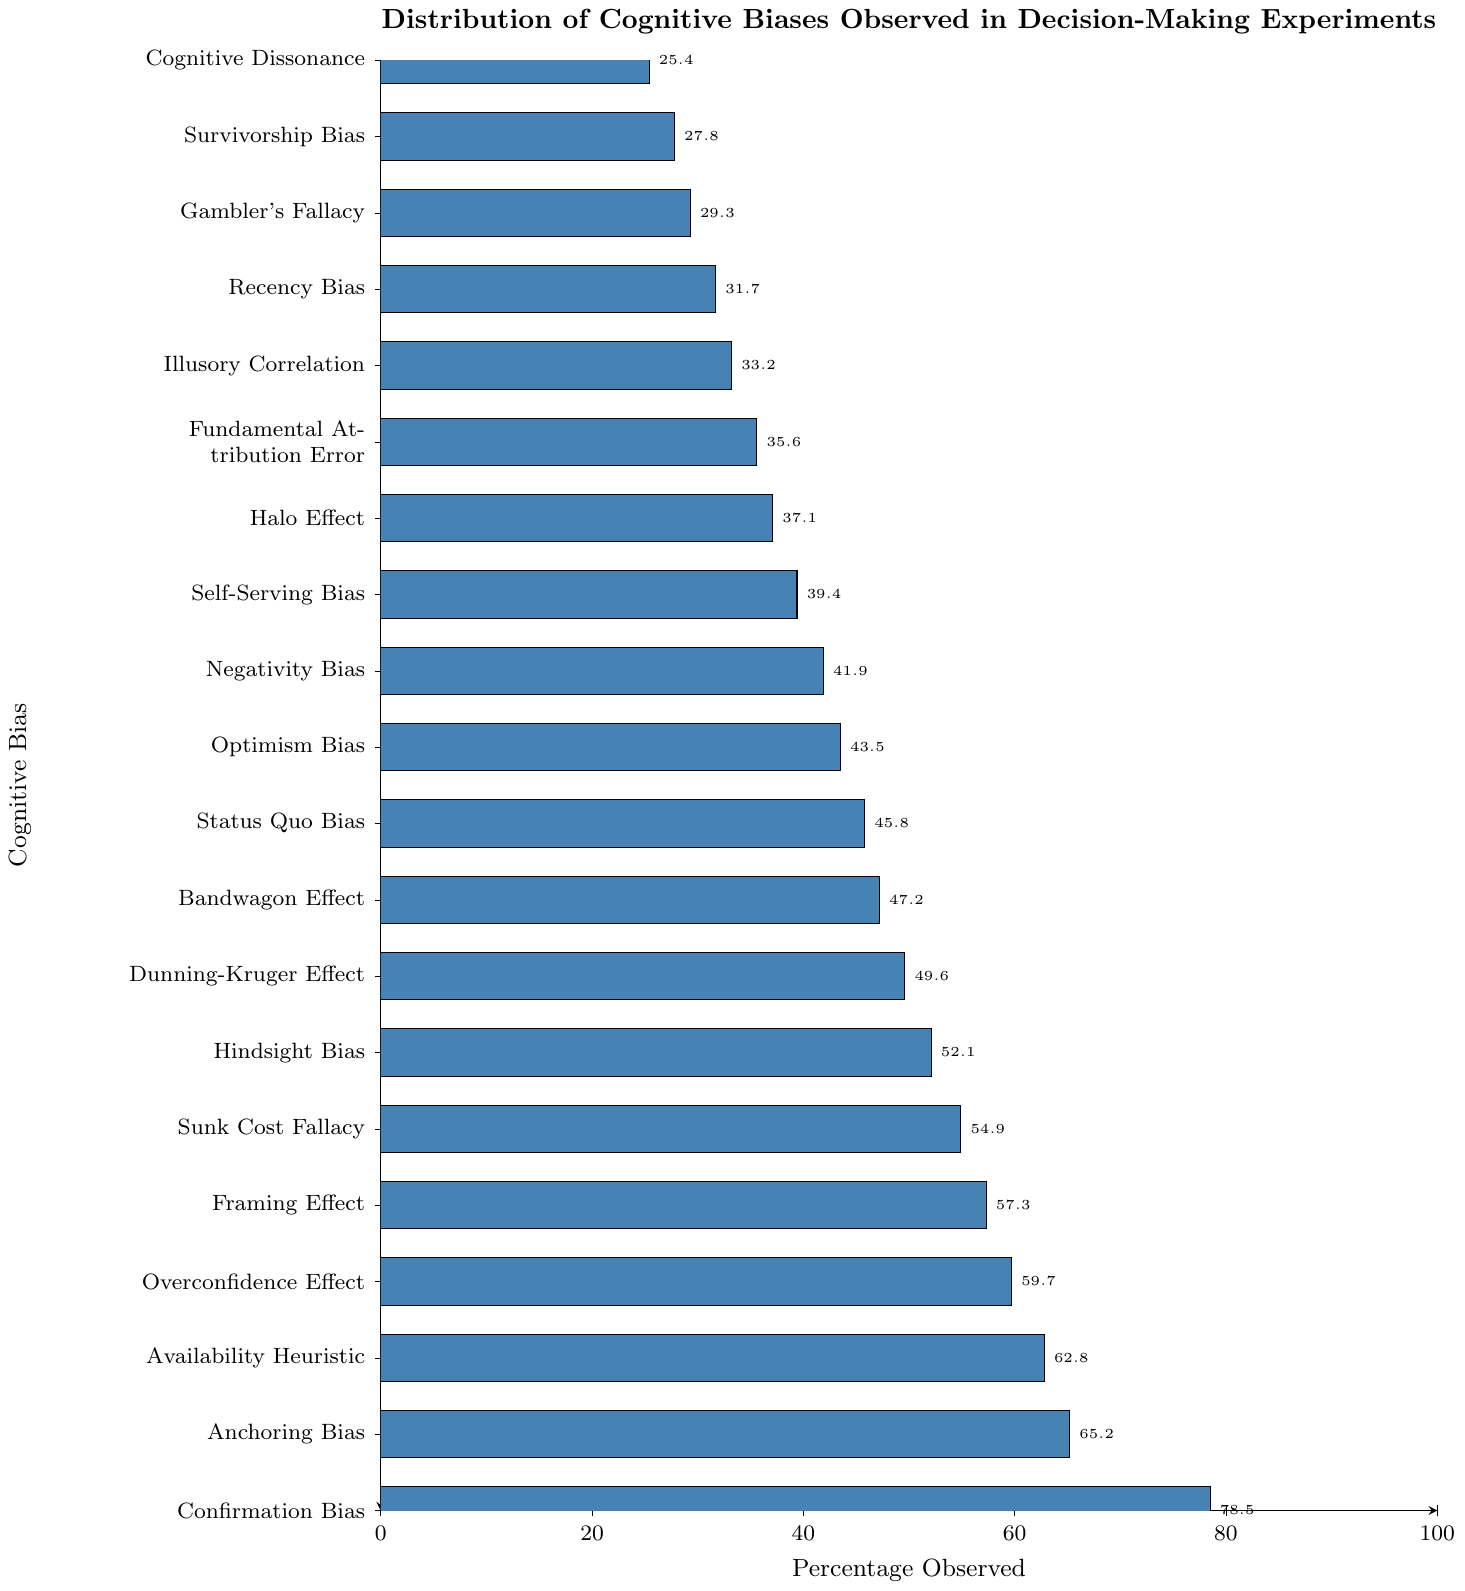Which cognitive bias has the highest observed percentage? To determine the cognitive bias with the highest observed percentage, look for the longest bar on the chart. The bar with the highest percentage is Confirmation Bias.
Answer: Confirmation Bias Which cognitive bias has the lowest observed percentage? To find the cognitive bias with the lowest observed percentage, look for the shortest bar on the chart. The bar with the lowest percentage is Cognitive Dissonance.
Answer: Cognitive Dissonance How much greater is the observed percentage of Confirmation Bias compared to Cognitive Dissonance? To find this, subtract the percentage of Cognitive Dissonance from the percentage of Confirmation Bias (78.5% - 25.4%).
Answer: 53.1% Which is observed more frequently: Anchoring Bias or Availability Heuristic? To compare these two, examine the bars corresponding to Anchoring Bias and Availability Heuristic. The length of the bar for Anchoring Bias is longer than that of Availability Heuristic.
Answer: Anchoring Bias What is the average observed percentage of Confirmation Bias, Anchoring Bias, and Availability Heuristic? To find this, sum their observed percentages and divide by the number of biases: (78.5% + 65.2% + 62.8%) / 3 = 68.83%.
Answer: 68.83% Which biases have an observed percentage above 50%? Check the bars with percentages above the 50% tick mark. Biases above this mark are: Confirmation Bias, Anchoring Bias, Availability Heuristic, Overconfidence Effect, Framing Effect, Sunk Cost Fallacy, Hindsight Bias, and Dunning-Kruger Effect.
Answer: Confirmation Bias, Anchoring Bias, Availability Heuristic, Overconfidence Effect, Framing Effect, Sunk Cost Fallacy, Hindsight Bias, Dunning-Kruger Effect What is the observed percentage difference between Overconfidence Effect and Optimism Bias? Subtract the percentage of Optimism Bias from that of Overconfidence Effect (59.7% - 43.5%) to find the difference.
Answer: 16.2% Are there more cognitive biases with observed percentages below or above 50%? Count the number of bars below and above the 50% mark. There are 12 bars below 50% and 8 bars above 50%. So, more cognitive biases have percentages below 50%.
Answer: Below 50% Which cognitive biases have an observed percentage closest to 40%? Look for bars around the 40% tick mark. Self-Serving Bias (39.4%) and Negativity Bias (41.9%) are closest to 40%.
Answer: Self-Serving Bias, Negativity Bias 